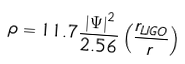Convert formula to latex. <formula><loc_0><loc_0><loc_500><loc_500>\rho = 1 1 . 7 \frac { { | \Psi | } ^ { 2 } } { 2 . 5 6 } \left ( \frac { r _ { L I G O } } { r } \right )</formula> 